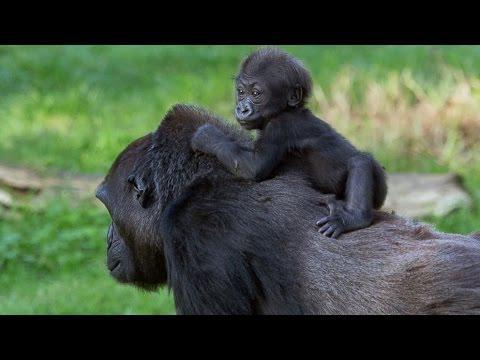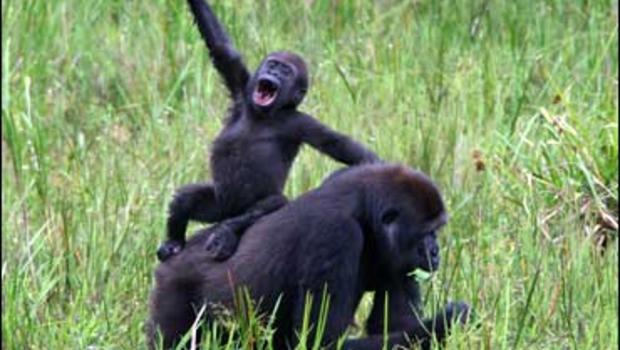The first image is the image on the left, the second image is the image on the right. Evaluate the accuracy of this statement regarding the images: "Each image features one baby gorilla in contact with one adult gorilla, and one image shows a baby gorilla riding on the back of an adult gorilla.". Is it true? Answer yes or no. Yes. The first image is the image on the left, the second image is the image on the right. Given the left and right images, does the statement "Both pictures have an adult gorilla with a young gorilla." hold true? Answer yes or no. Yes. 